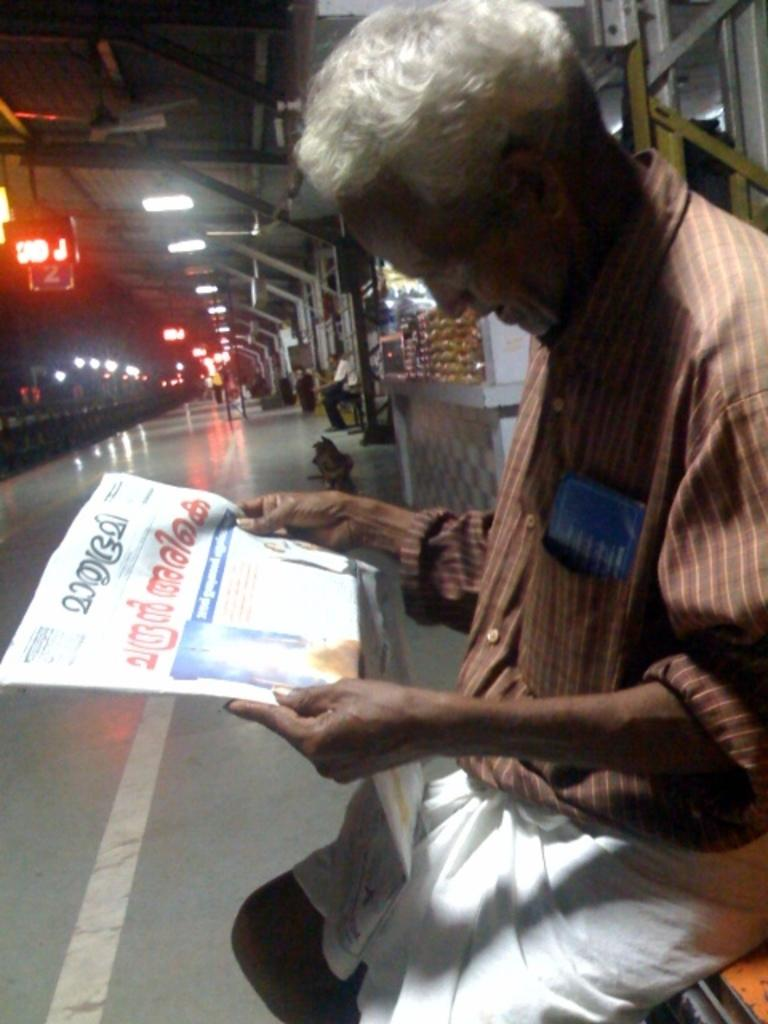What is the main structure in the image? There is a platform in the image. What are the people on the platform doing? There are people sitting on the platform. Can you describe the person holding an object on the platform? There is a person holding a newspaper. What type of lighting is visible in the image? There are lights visible in the image. What other structures can be seen in the image? There are poles in the image. What type of establishments are present in the image? There are stores in the image. What is the color of the LED board in the image? There is a red-colored LED board in the image. How does the lettuce get distributed to the stores in the image? There is no lettuce or distribution process mentioned or visible in the image. 